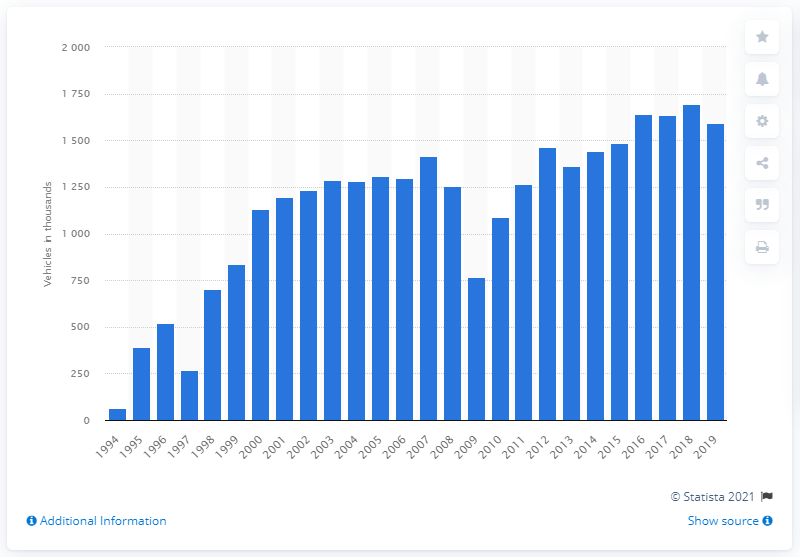Give some essential details in this illustration. The number of freight vehicles on the Le Shuttle dropped in 2009. 